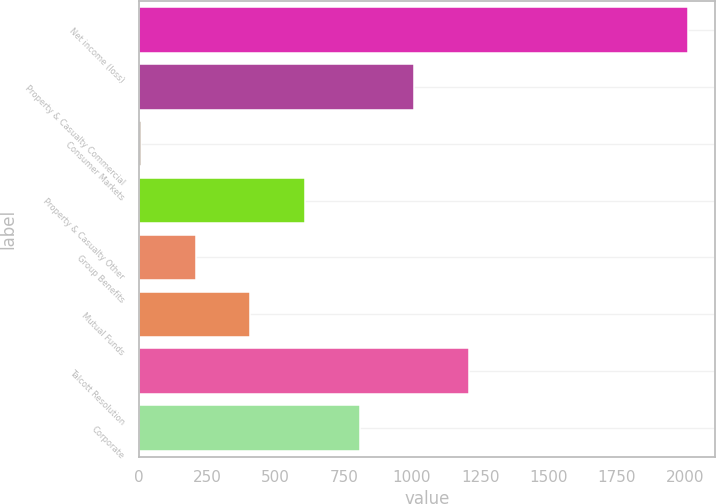Convert chart. <chart><loc_0><loc_0><loc_500><loc_500><bar_chart><fcel>Net income (loss)<fcel>Property & Casualty Commercial<fcel>Consumer Markets<fcel>Property & Casualty Other<fcel>Group Benefits<fcel>Mutual Funds<fcel>Talcott Resolution<fcel>Corporate<nl><fcel>2011<fcel>1009<fcel>7<fcel>608.2<fcel>207.4<fcel>407.8<fcel>1209.4<fcel>808.6<nl></chart> 